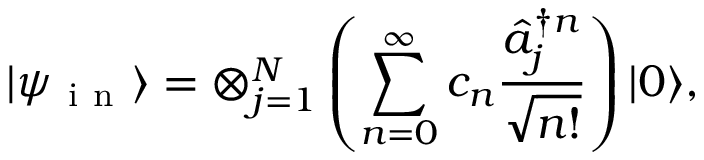<formula> <loc_0><loc_0><loc_500><loc_500>| \psi _ { i n } \rangle = \otimes _ { j = 1 } ^ { N } \left ( \sum _ { n = 0 } ^ { \infty } c _ { n } \frac { \hat { a } _ { j } ^ { \dag n } } { \sqrt { n ! } } \right ) | 0 \rangle ,</formula> 